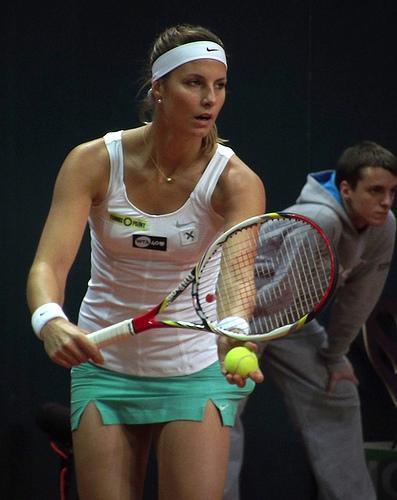How many people are pictured?
Give a very brief answer. 2. 